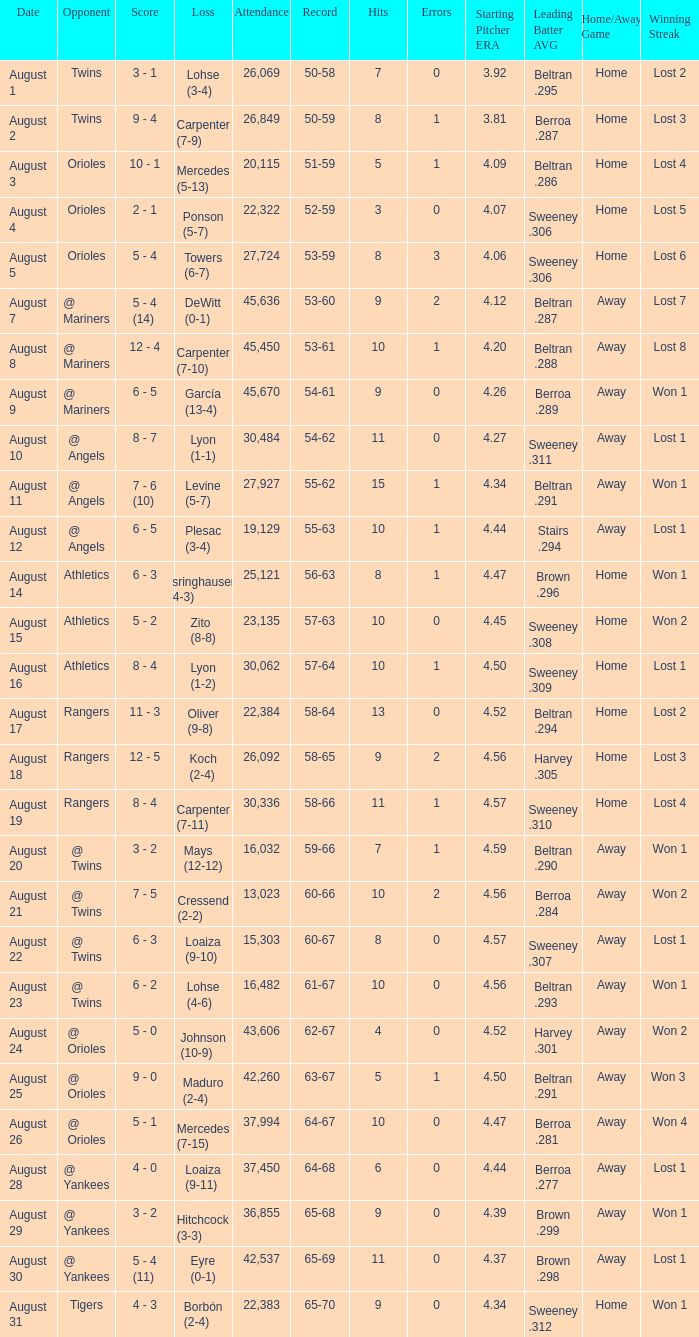What was the score of the game when their record was 62-67 5 - 0. 